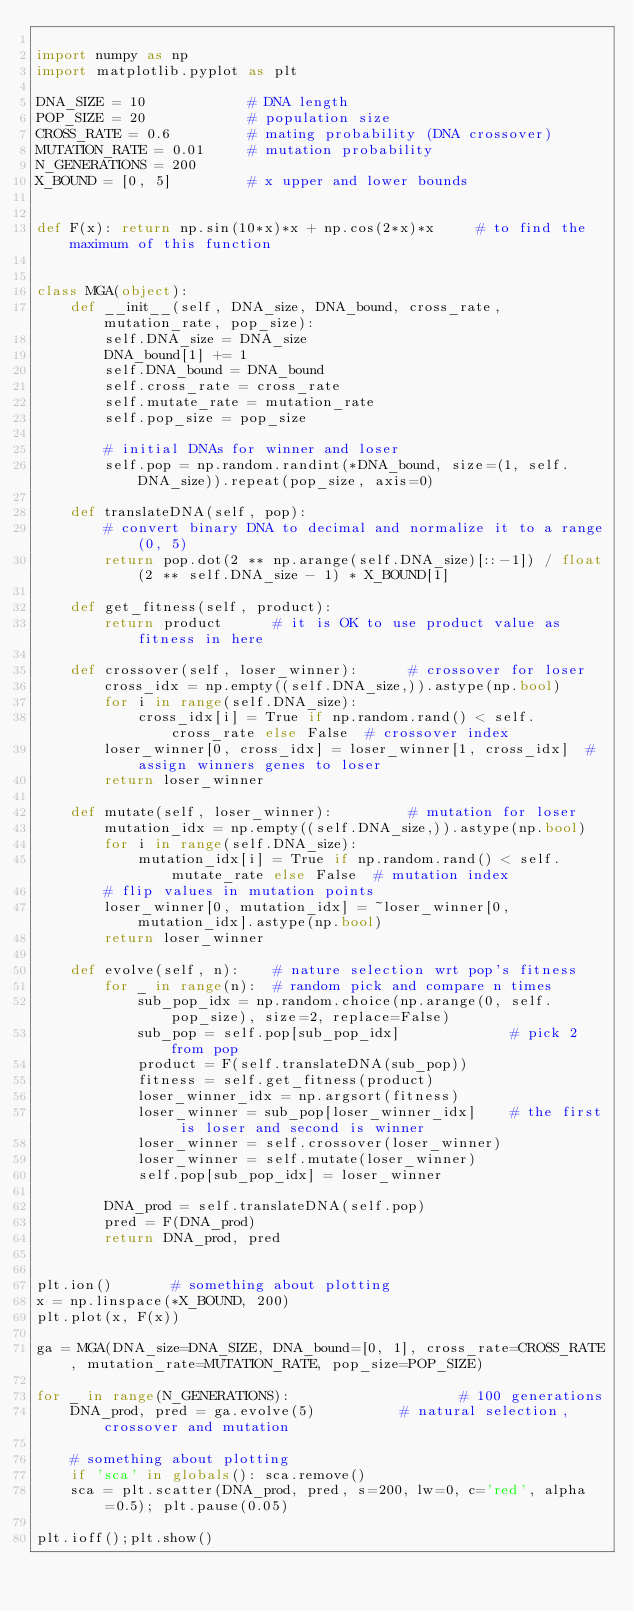<code> <loc_0><loc_0><loc_500><loc_500><_Python_>
import numpy as np
import matplotlib.pyplot as plt

DNA_SIZE = 10            # DNA length
POP_SIZE = 20            # population size
CROSS_RATE = 0.6         # mating probability (DNA crossover)
MUTATION_RATE = 0.01     # mutation probability
N_GENERATIONS = 200
X_BOUND = [0, 5]         # x upper and lower bounds


def F(x): return np.sin(10*x)*x + np.cos(2*x)*x     # to find the maximum of this function


class MGA(object):
    def __init__(self, DNA_size, DNA_bound, cross_rate, mutation_rate, pop_size):
        self.DNA_size = DNA_size
        DNA_bound[1] += 1
        self.DNA_bound = DNA_bound
        self.cross_rate = cross_rate
        self.mutate_rate = mutation_rate
        self.pop_size = pop_size

        # initial DNAs for winner and loser
        self.pop = np.random.randint(*DNA_bound, size=(1, self.DNA_size)).repeat(pop_size, axis=0)

    def translateDNA(self, pop):
        # convert binary DNA to decimal and normalize it to a range(0, 5)
        return pop.dot(2 ** np.arange(self.DNA_size)[::-1]) / float(2 ** self.DNA_size - 1) * X_BOUND[1]

    def get_fitness(self, product):
        return product      # it is OK to use product value as fitness in here

    def crossover(self, loser_winner):      # crossover for loser
        cross_idx = np.empty((self.DNA_size,)).astype(np.bool)
        for i in range(self.DNA_size):
            cross_idx[i] = True if np.random.rand() < self.cross_rate else False  # crossover index
        loser_winner[0, cross_idx] = loser_winner[1, cross_idx]  # assign winners genes to loser
        return loser_winner

    def mutate(self, loser_winner):         # mutation for loser
        mutation_idx = np.empty((self.DNA_size,)).astype(np.bool)
        for i in range(self.DNA_size):
            mutation_idx[i] = True if np.random.rand() < self.mutate_rate else False  # mutation index
        # flip values in mutation points
        loser_winner[0, mutation_idx] = ~loser_winner[0, mutation_idx].astype(np.bool)
        return loser_winner

    def evolve(self, n):    # nature selection wrt pop's fitness
        for _ in range(n):  # random pick and compare n times
            sub_pop_idx = np.random.choice(np.arange(0, self.pop_size), size=2, replace=False)
            sub_pop = self.pop[sub_pop_idx]             # pick 2 from pop
            product = F(self.translateDNA(sub_pop))
            fitness = self.get_fitness(product)
            loser_winner_idx = np.argsort(fitness)
            loser_winner = sub_pop[loser_winner_idx]    # the first is loser and second is winner
            loser_winner = self.crossover(loser_winner)
            loser_winner = self.mutate(loser_winner)
            self.pop[sub_pop_idx] = loser_winner

        DNA_prod = self.translateDNA(self.pop)
        pred = F(DNA_prod)
        return DNA_prod, pred


plt.ion()       # something about plotting
x = np.linspace(*X_BOUND, 200)
plt.plot(x, F(x))

ga = MGA(DNA_size=DNA_SIZE, DNA_bound=[0, 1], cross_rate=CROSS_RATE, mutation_rate=MUTATION_RATE, pop_size=POP_SIZE)

for _ in range(N_GENERATIONS):                    # 100 generations
    DNA_prod, pred = ga.evolve(5)          # natural selection, crossover and mutation

    # something about plotting
    if 'sca' in globals(): sca.remove()
    sca = plt.scatter(DNA_prod, pred, s=200, lw=0, c='red', alpha=0.5); plt.pause(0.05)

plt.ioff();plt.show()</code> 